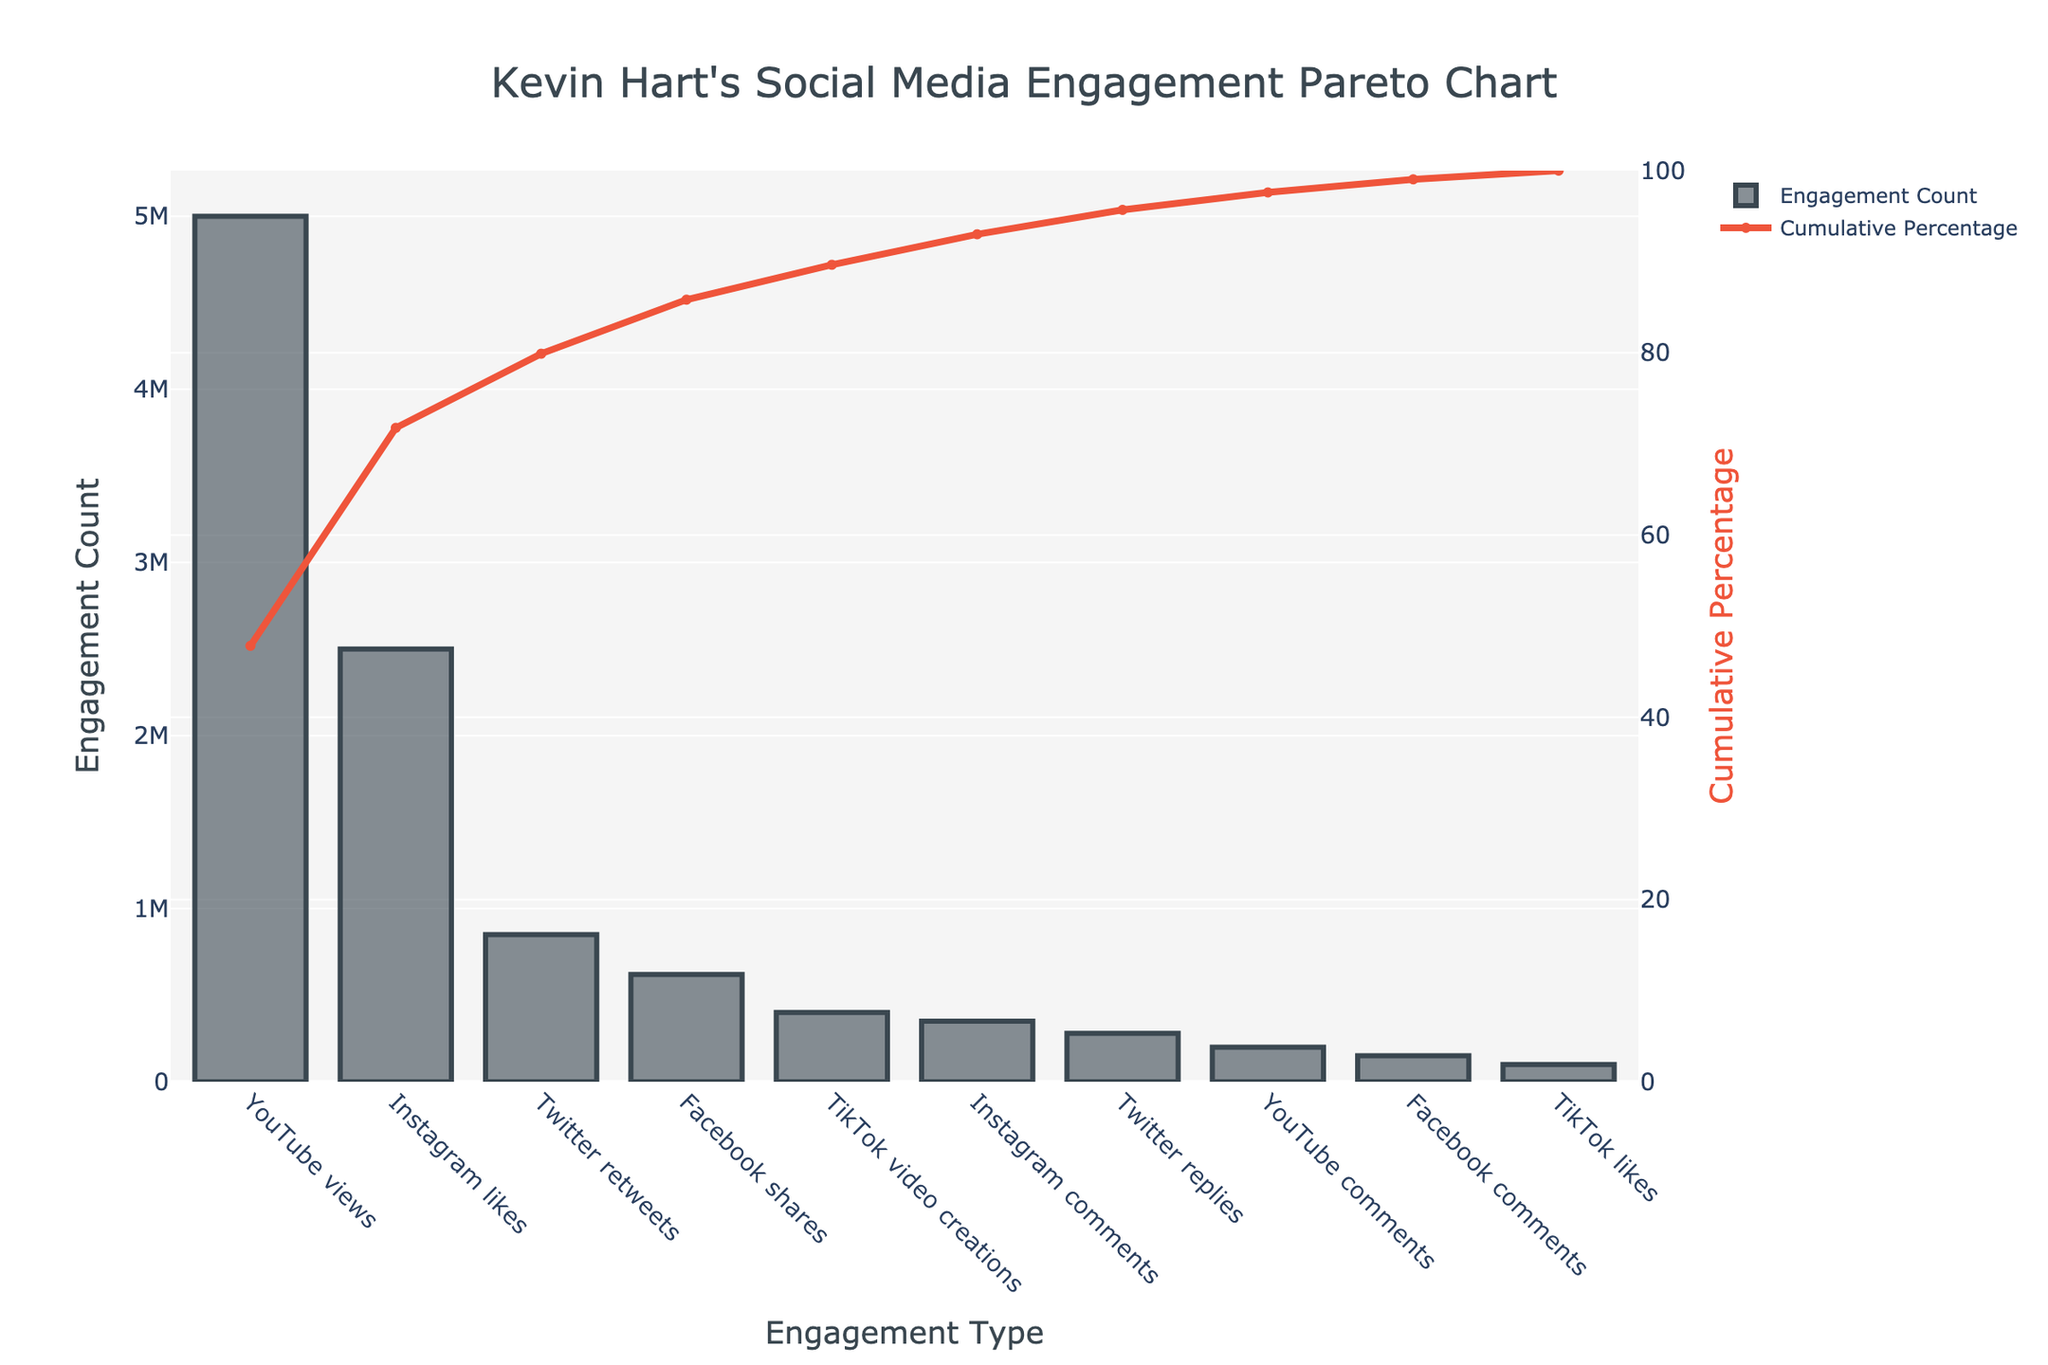what is the title of the chart? The title of the chart is prominently displayed at the top center of the figure. The exact text of the title can be read directly from this location.
Answer: Kevin Hart's Social Media Engagement Pareto Chart Which social media platform has the highest engagement count? The bar with the tallest height represents the highest engagement count. By looking at the label below this bar, we can identify the platform.
Answer: YouTube views What is the engagement count for Instagram likes? Find the bar labeled "Instagram likes" along the x-axis and then refer to the height of this bar on the y-axis which represents the engagement count.
Answer: 2,500,000 What is the cumulative percentage after including Facebook shares? To find this, locate the "Facebook shares" on the x-axis, then refer to the value on the secondary y-axis (right side) associated with the cumulative percentage line at that point.
Answer: Around 90% How many categories have engagement counts greater than 500,000? Look along the y-axis for the 500,000 mark and count how many bars are taller than this mark.
Answer: 4 Between Twitter retweets and Facebook shares, which has a higher engagement count? Compare the heights of the bars labeled "Twitter retweets" and "Facebook shares."
Answer: Twitter retweets Which category contributes the least to the cumulative engagement percentage? Find the category with the smallest bar on the left-hand y-axis and correspond it to the point on the x-axis.
Answer: TikTok likes What is the difference in engagement count between YouTube views and Instagram likes? Subtract the engagement count of Instagram likes from the engagement count of YouTube views.
Answer: 2,500,000 What is the cumulative percentage after including Instagram likes? Locate "Instagram likes" on the x-axis, then look at the cumulative percentage curve to find corresponding value on the secondary y-axis.
Answer: Around 35% What observations can you make about the first three categories in terms of their impact on social media engagement? Examine the heights of the first three bars and their corresponding cumulative percentages to understand their proportions and collective impact.
Answer: They dominate the engagement, reaching over 80% cumulatively 